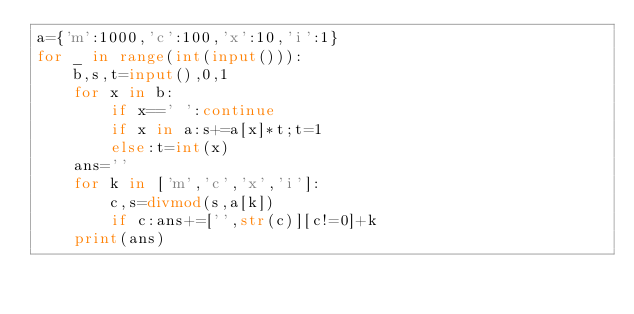Convert code to text. <code><loc_0><loc_0><loc_500><loc_500><_Python_>a={'m':1000,'c':100,'x':10,'i':1}
for _ in range(int(input())):
    b,s,t=input(),0,1
    for x in b:
        if x==' ':continue
        if x in a:s+=a[x]*t;t=1
        else:t=int(x)
    ans=''
    for k in ['m','c','x','i']:
        c,s=divmod(s,a[k])
        if c:ans+=['',str(c)][c!=0]+k
    print(ans)</code> 